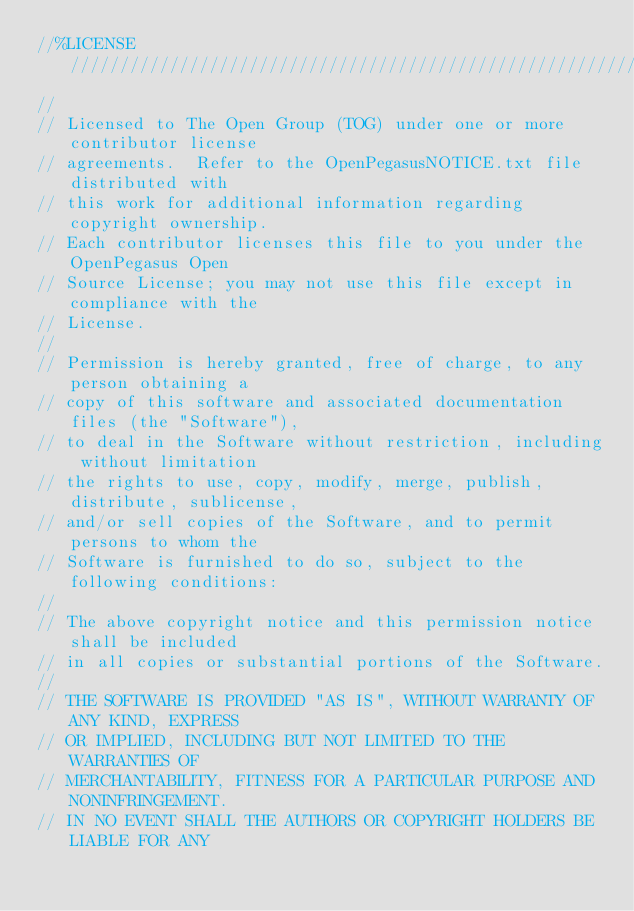Convert code to text. <code><loc_0><loc_0><loc_500><loc_500><_C++_>//%LICENSE////////////////////////////////////////////////////////////////
//
// Licensed to The Open Group (TOG) under one or more contributor license
// agreements.  Refer to the OpenPegasusNOTICE.txt file distributed with
// this work for additional information regarding copyright ownership.
// Each contributor licenses this file to you under the OpenPegasus Open
// Source License; you may not use this file except in compliance with the
// License.
//
// Permission is hereby granted, free of charge, to any person obtaining a
// copy of this software and associated documentation files (the "Software"),
// to deal in the Software without restriction, including without limitation
// the rights to use, copy, modify, merge, publish, distribute, sublicense,
// and/or sell copies of the Software, and to permit persons to whom the
// Software is furnished to do so, subject to the following conditions:
//
// The above copyright notice and this permission notice shall be included
// in all copies or substantial portions of the Software.
//
// THE SOFTWARE IS PROVIDED "AS IS", WITHOUT WARRANTY OF ANY KIND, EXPRESS
// OR IMPLIED, INCLUDING BUT NOT LIMITED TO THE WARRANTIES OF
// MERCHANTABILITY, FITNESS FOR A PARTICULAR PURPOSE AND NONINFRINGEMENT.
// IN NO EVENT SHALL THE AUTHORS OR COPYRIGHT HOLDERS BE LIABLE FOR ANY</code> 